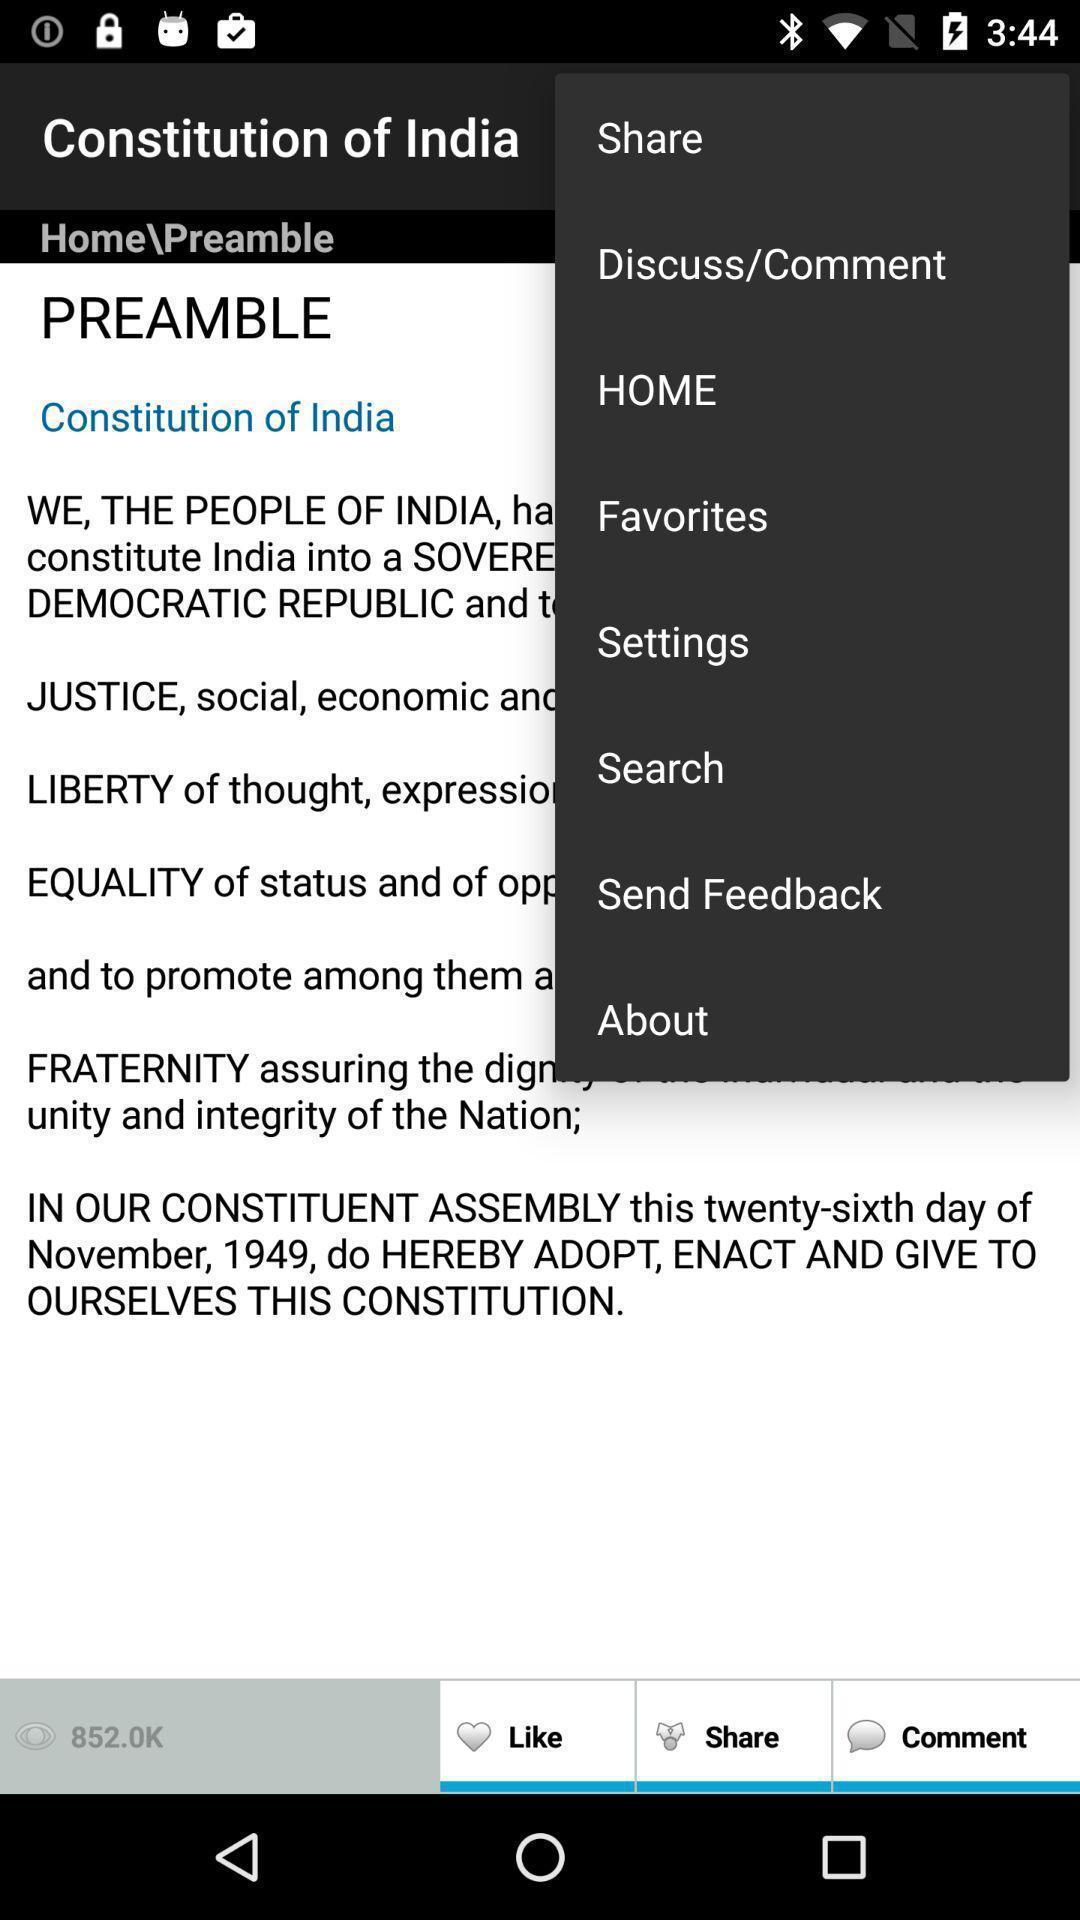Describe this image in words. Pop-up showing list of various options. 